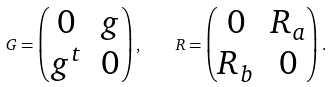Convert formula to latex. <formula><loc_0><loc_0><loc_500><loc_500>G = \begin{pmatrix} 0 & g \\ g ^ { t } & 0 \end{pmatrix} , \quad R = \begin{pmatrix} 0 & R _ { a } \\ R _ { b } & 0 \end{pmatrix} .</formula> 